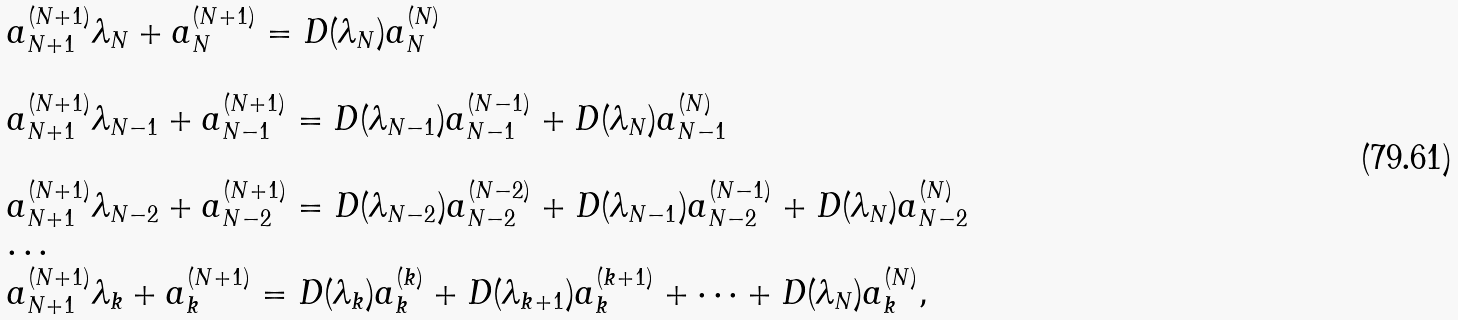Convert formula to latex. <formula><loc_0><loc_0><loc_500><loc_500>\begin{array} { l } a ^ { ( N + 1 ) } _ { N + 1 } \lambda _ { N } + a ^ { ( N + 1 ) } _ { N } = D ( \lambda _ { N } ) a ^ { ( N ) } _ { N } \\ \\ a ^ { ( N + 1 ) } _ { N + 1 } \lambda _ { N - 1 } + a ^ { ( N + 1 ) } _ { N - 1 } = D ( \lambda _ { N - 1 } ) a ^ { ( N - 1 ) } _ { N - 1 } + D ( \lambda _ { N } ) a ^ { ( N ) } _ { N - 1 } \\ \\ a ^ { ( N + 1 ) } _ { N + 1 } \lambda _ { N - 2 } + a ^ { ( N + 1 ) } _ { N - 2 } = D ( \lambda _ { N - 2 } ) a ^ { ( N - 2 ) } _ { N - 2 } + D ( \lambda _ { N - 1 } ) a ^ { ( N - 1 ) } _ { N - 2 } + D ( \lambda _ { N } ) a ^ { ( N ) } _ { N - 2 } \\ \dots \\ a ^ { ( N + 1 ) } _ { N + 1 } \lambda _ { k } + a ^ { ( N + 1 ) } _ { k } = D ( \lambda _ { k } ) a ^ { ( k ) } _ { k } + D ( \lambda _ { k + 1 } ) a ^ { ( k + 1 ) } _ { k } + \dots + D ( \lambda _ { N } ) a ^ { ( N ) } _ { k } , \end{array}</formula> 